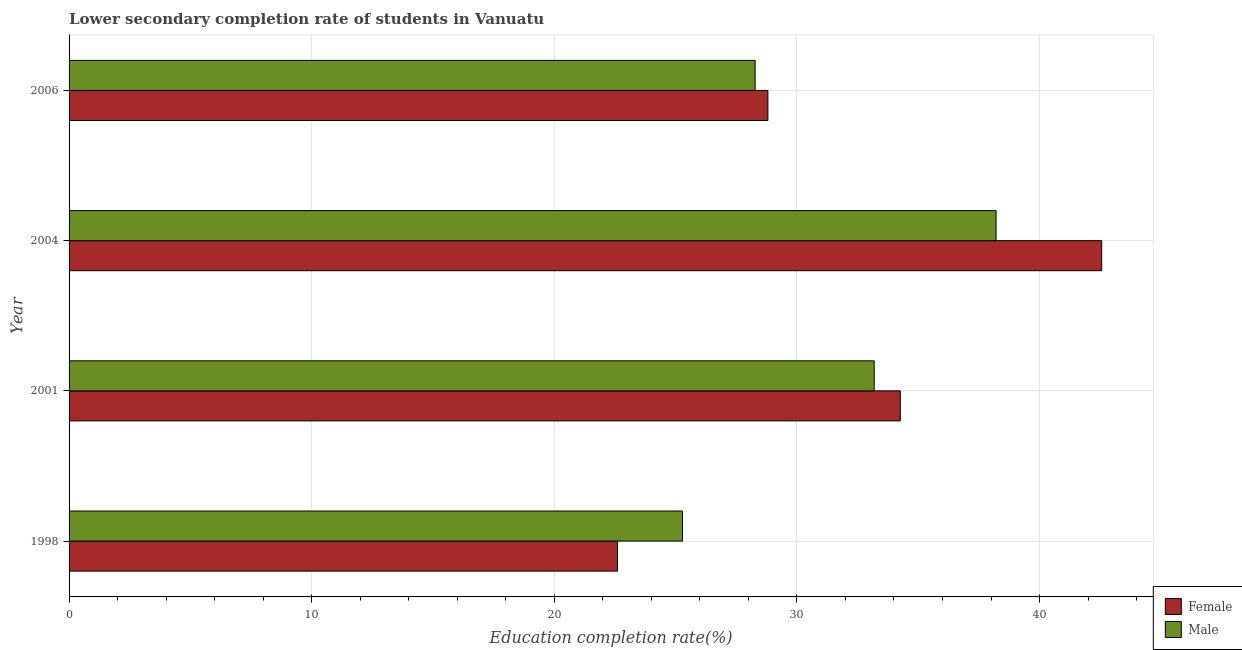How many different coloured bars are there?
Your response must be concise. 2. How many groups of bars are there?
Offer a terse response. 4. How many bars are there on the 1st tick from the bottom?
Keep it short and to the point. 2. In how many cases, is the number of bars for a given year not equal to the number of legend labels?
Your response must be concise. 0. What is the education completion rate of female students in 2006?
Give a very brief answer. 28.8. Across all years, what is the maximum education completion rate of male students?
Your answer should be compact. 38.21. Across all years, what is the minimum education completion rate of male students?
Offer a very short reply. 25.28. In which year was the education completion rate of male students minimum?
Offer a very short reply. 1998. What is the total education completion rate of female students in the graph?
Offer a very short reply. 128.24. What is the difference between the education completion rate of female students in 2001 and that in 2004?
Ensure brevity in your answer.  -8.3. What is the difference between the education completion rate of male students in 2004 and the education completion rate of female students in 2001?
Ensure brevity in your answer.  3.95. What is the average education completion rate of male students per year?
Your answer should be very brief. 31.24. In the year 2006, what is the difference between the education completion rate of male students and education completion rate of female students?
Ensure brevity in your answer.  -0.53. What is the ratio of the education completion rate of male students in 2001 to that in 2006?
Your answer should be very brief. 1.17. Is the difference between the education completion rate of male students in 2001 and 2004 greater than the difference between the education completion rate of female students in 2001 and 2004?
Ensure brevity in your answer.  Yes. What is the difference between the highest and the second highest education completion rate of female students?
Provide a short and direct response. 8.3. What is the difference between the highest and the lowest education completion rate of male students?
Make the answer very short. 12.92. What does the 1st bar from the bottom in 2001 represents?
Your answer should be very brief. Female. Are all the bars in the graph horizontal?
Give a very brief answer. Yes. How many years are there in the graph?
Make the answer very short. 4. What is the difference between two consecutive major ticks on the X-axis?
Keep it short and to the point. 10. Are the values on the major ticks of X-axis written in scientific E-notation?
Offer a terse response. No. Does the graph contain any zero values?
Your answer should be compact. No. Does the graph contain grids?
Offer a terse response. Yes. Where does the legend appear in the graph?
Your answer should be very brief. Bottom right. What is the title of the graph?
Ensure brevity in your answer.  Lower secondary completion rate of students in Vanuatu. Does "Girls" appear as one of the legend labels in the graph?
Provide a succinct answer. No. What is the label or title of the X-axis?
Make the answer very short. Education completion rate(%). What is the label or title of the Y-axis?
Give a very brief answer. Year. What is the Education completion rate(%) of Female in 1998?
Make the answer very short. 22.61. What is the Education completion rate(%) of Male in 1998?
Offer a very short reply. 25.28. What is the Education completion rate(%) in Female in 2001?
Give a very brief answer. 34.26. What is the Education completion rate(%) in Male in 2001?
Ensure brevity in your answer.  33.19. What is the Education completion rate(%) in Female in 2004?
Your response must be concise. 42.56. What is the Education completion rate(%) in Male in 2004?
Offer a very short reply. 38.21. What is the Education completion rate(%) in Female in 2006?
Your answer should be compact. 28.8. What is the Education completion rate(%) of Male in 2006?
Keep it short and to the point. 28.28. Across all years, what is the maximum Education completion rate(%) of Female?
Offer a very short reply. 42.56. Across all years, what is the maximum Education completion rate(%) of Male?
Your response must be concise. 38.21. Across all years, what is the minimum Education completion rate(%) in Female?
Offer a very short reply. 22.61. Across all years, what is the minimum Education completion rate(%) of Male?
Offer a very short reply. 25.28. What is the total Education completion rate(%) in Female in the graph?
Give a very brief answer. 128.24. What is the total Education completion rate(%) in Male in the graph?
Ensure brevity in your answer.  124.96. What is the difference between the Education completion rate(%) in Female in 1998 and that in 2001?
Ensure brevity in your answer.  -11.66. What is the difference between the Education completion rate(%) in Male in 1998 and that in 2001?
Offer a very short reply. -7.9. What is the difference between the Education completion rate(%) in Female in 1998 and that in 2004?
Keep it short and to the point. -19.96. What is the difference between the Education completion rate(%) of Male in 1998 and that in 2004?
Give a very brief answer. -12.92. What is the difference between the Education completion rate(%) of Female in 1998 and that in 2006?
Offer a terse response. -6.2. What is the difference between the Education completion rate(%) of Male in 1998 and that in 2006?
Your response must be concise. -2.99. What is the difference between the Education completion rate(%) of Female in 2001 and that in 2004?
Your answer should be very brief. -8.3. What is the difference between the Education completion rate(%) of Male in 2001 and that in 2004?
Give a very brief answer. -5.02. What is the difference between the Education completion rate(%) in Female in 2001 and that in 2006?
Provide a short and direct response. 5.46. What is the difference between the Education completion rate(%) in Male in 2001 and that in 2006?
Offer a terse response. 4.91. What is the difference between the Education completion rate(%) of Female in 2004 and that in 2006?
Provide a short and direct response. 13.76. What is the difference between the Education completion rate(%) of Male in 2004 and that in 2006?
Provide a succinct answer. 9.93. What is the difference between the Education completion rate(%) of Female in 1998 and the Education completion rate(%) of Male in 2001?
Offer a very short reply. -10.58. What is the difference between the Education completion rate(%) of Female in 1998 and the Education completion rate(%) of Male in 2004?
Give a very brief answer. -15.6. What is the difference between the Education completion rate(%) in Female in 1998 and the Education completion rate(%) in Male in 2006?
Offer a terse response. -5.67. What is the difference between the Education completion rate(%) in Female in 2001 and the Education completion rate(%) in Male in 2004?
Provide a short and direct response. -3.95. What is the difference between the Education completion rate(%) in Female in 2001 and the Education completion rate(%) in Male in 2006?
Offer a terse response. 5.98. What is the difference between the Education completion rate(%) of Female in 2004 and the Education completion rate(%) of Male in 2006?
Ensure brevity in your answer.  14.28. What is the average Education completion rate(%) of Female per year?
Offer a terse response. 32.06. What is the average Education completion rate(%) of Male per year?
Your response must be concise. 31.24. In the year 1998, what is the difference between the Education completion rate(%) in Female and Education completion rate(%) in Male?
Ensure brevity in your answer.  -2.68. In the year 2001, what is the difference between the Education completion rate(%) of Female and Education completion rate(%) of Male?
Offer a terse response. 1.08. In the year 2004, what is the difference between the Education completion rate(%) of Female and Education completion rate(%) of Male?
Your answer should be very brief. 4.35. In the year 2006, what is the difference between the Education completion rate(%) in Female and Education completion rate(%) in Male?
Your answer should be compact. 0.53. What is the ratio of the Education completion rate(%) in Female in 1998 to that in 2001?
Offer a very short reply. 0.66. What is the ratio of the Education completion rate(%) of Male in 1998 to that in 2001?
Keep it short and to the point. 0.76. What is the ratio of the Education completion rate(%) in Female in 1998 to that in 2004?
Offer a terse response. 0.53. What is the ratio of the Education completion rate(%) in Male in 1998 to that in 2004?
Ensure brevity in your answer.  0.66. What is the ratio of the Education completion rate(%) of Female in 1998 to that in 2006?
Ensure brevity in your answer.  0.78. What is the ratio of the Education completion rate(%) in Male in 1998 to that in 2006?
Your answer should be compact. 0.89. What is the ratio of the Education completion rate(%) in Female in 2001 to that in 2004?
Offer a very short reply. 0.81. What is the ratio of the Education completion rate(%) in Male in 2001 to that in 2004?
Offer a terse response. 0.87. What is the ratio of the Education completion rate(%) in Female in 2001 to that in 2006?
Keep it short and to the point. 1.19. What is the ratio of the Education completion rate(%) of Male in 2001 to that in 2006?
Your answer should be very brief. 1.17. What is the ratio of the Education completion rate(%) of Female in 2004 to that in 2006?
Offer a terse response. 1.48. What is the ratio of the Education completion rate(%) in Male in 2004 to that in 2006?
Make the answer very short. 1.35. What is the difference between the highest and the second highest Education completion rate(%) in Female?
Offer a terse response. 8.3. What is the difference between the highest and the second highest Education completion rate(%) in Male?
Provide a succinct answer. 5.02. What is the difference between the highest and the lowest Education completion rate(%) of Female?
Provide a succinct answer. 19.96. What is the difference between the highest and the lowest Education completion rate(%) of Male?
Your response must be concise. 12.92. 